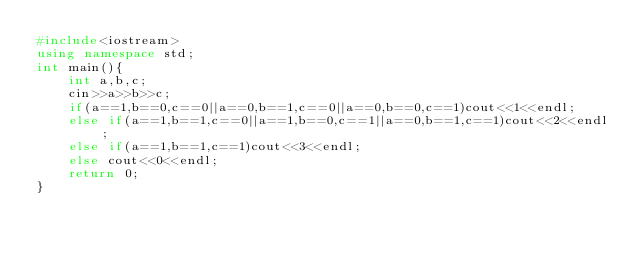<code> <loc_0><loc_0><loc_500><loc_500><_C++_>#include<iostream>
using namespace std;
int main(){
	int a,b,c;
	cin>>a>>b>>c;
	if(a==1,b==0,c==0||a==0,b==1,c==0||a==0,b==0,c==1)cout<<1<<endl;
    else if(a==1,b==1,c==0||a==1,b==0,c==1||a==0,b==1,c==1)cout<<2<<endl;
    else if(a==1,b==1,c==1)cout<<3<<endl;
    else cout<<0<<endl;
	return 0;
}
</code> 